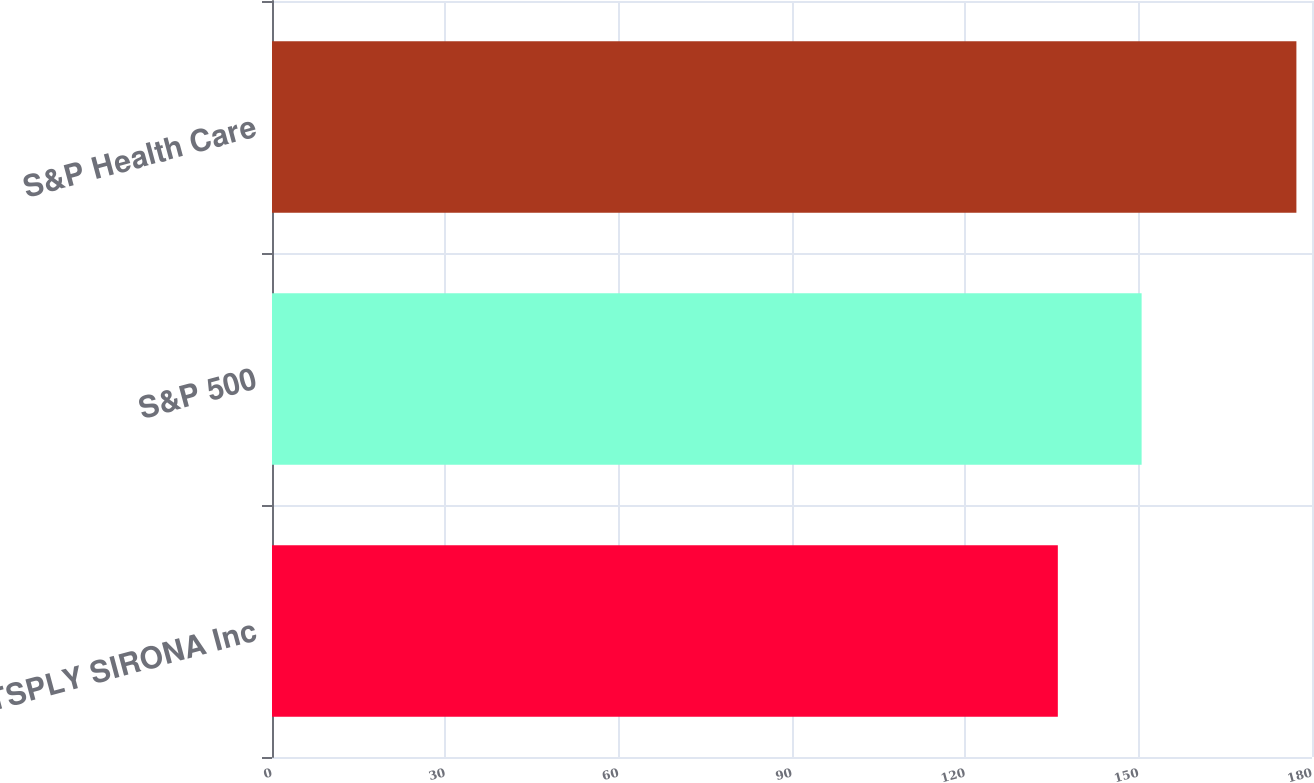Convert chart to OTSL. <chart><loc_0><loc_0><loc_500><loc_500><bar_chart><fcel>DENTSPLY SIRONA Inc<fcel>S&P 500<fcel>S&P Health Care<nl><fcel>136.01<fcel>150.51<fcel>177.3<nl></chart> 